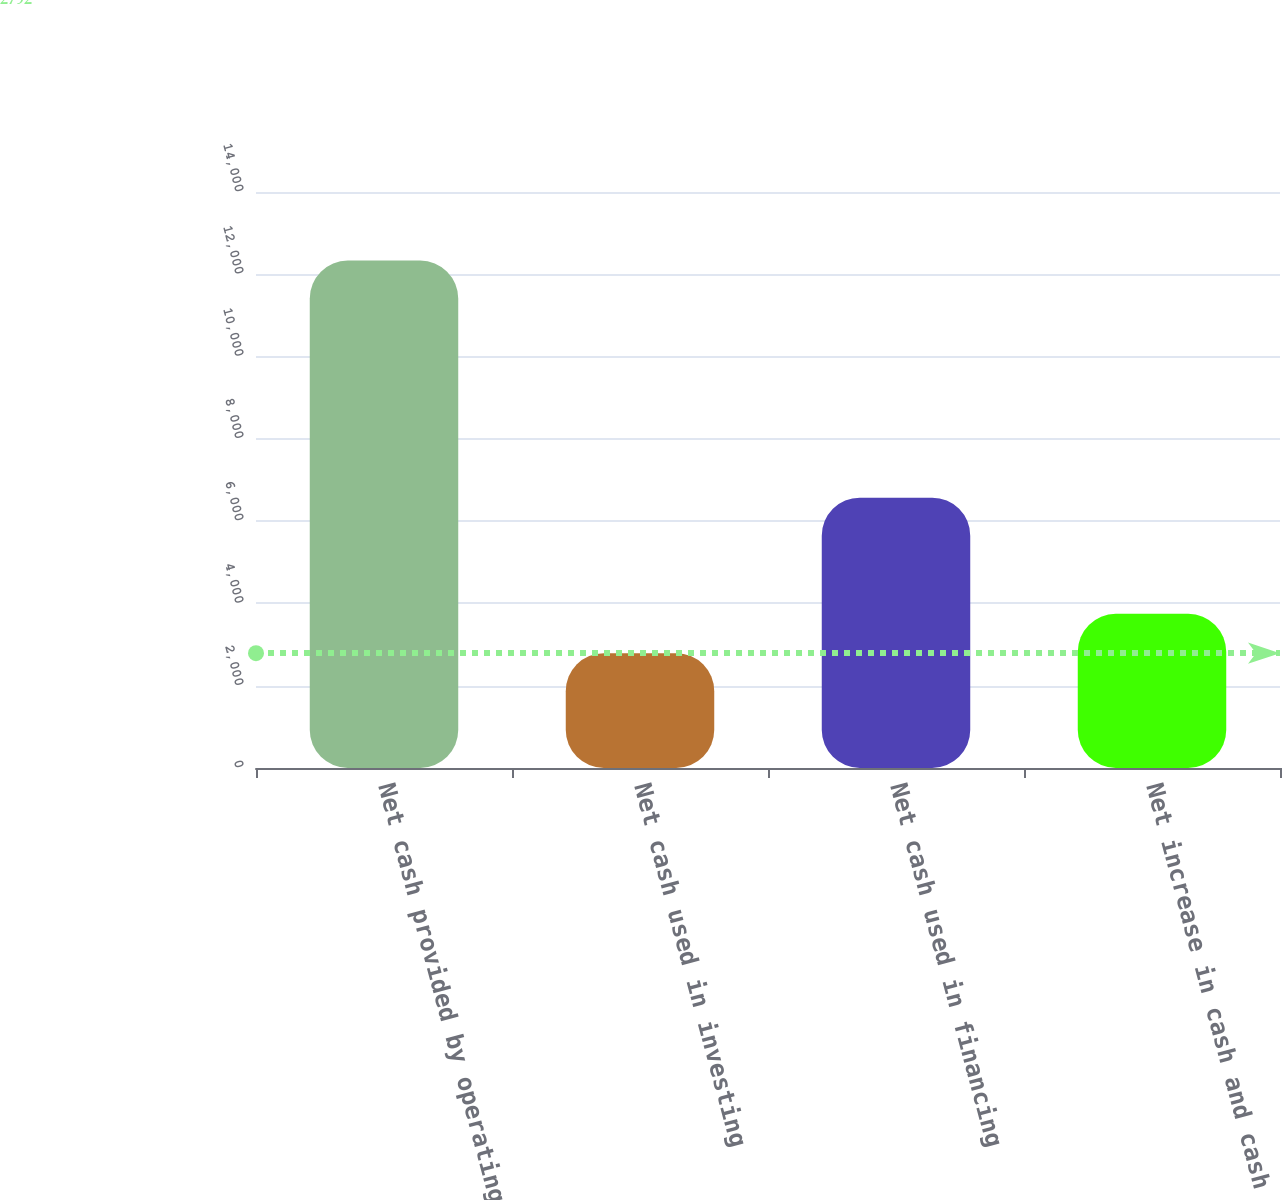Convert chart. <chart><loc_0><loc_0><loc_500><loc_500><bar_chart><fcel>Net cash provided by operating<fcel>Net cash used in investing<fcel>Net cash used in financing<fcel>Net increase in cash and cash<nl><fcel>12333<fcel>2792<fcel>6571<fcel>3746.1<nl></chart> 